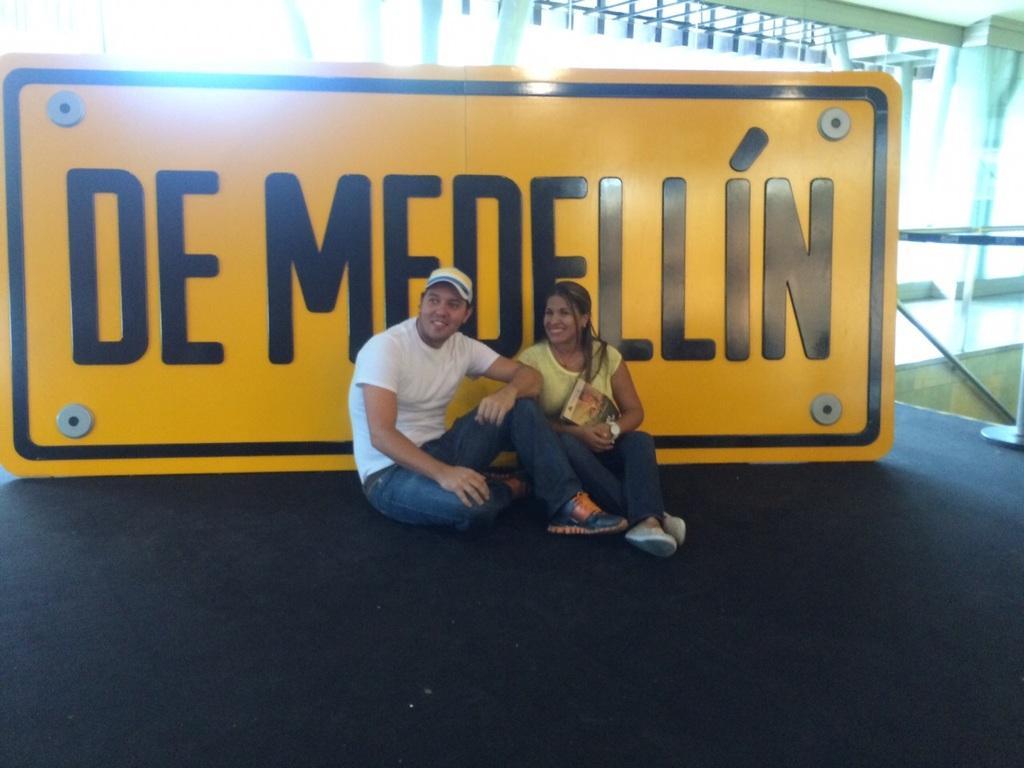Please provide a concise description of this image. In this picture we can see a man and a woman holding a book in her hand. Both are sitting on the path. There is a board and few lights in the background. We can see a glass and a stand on the right side. 